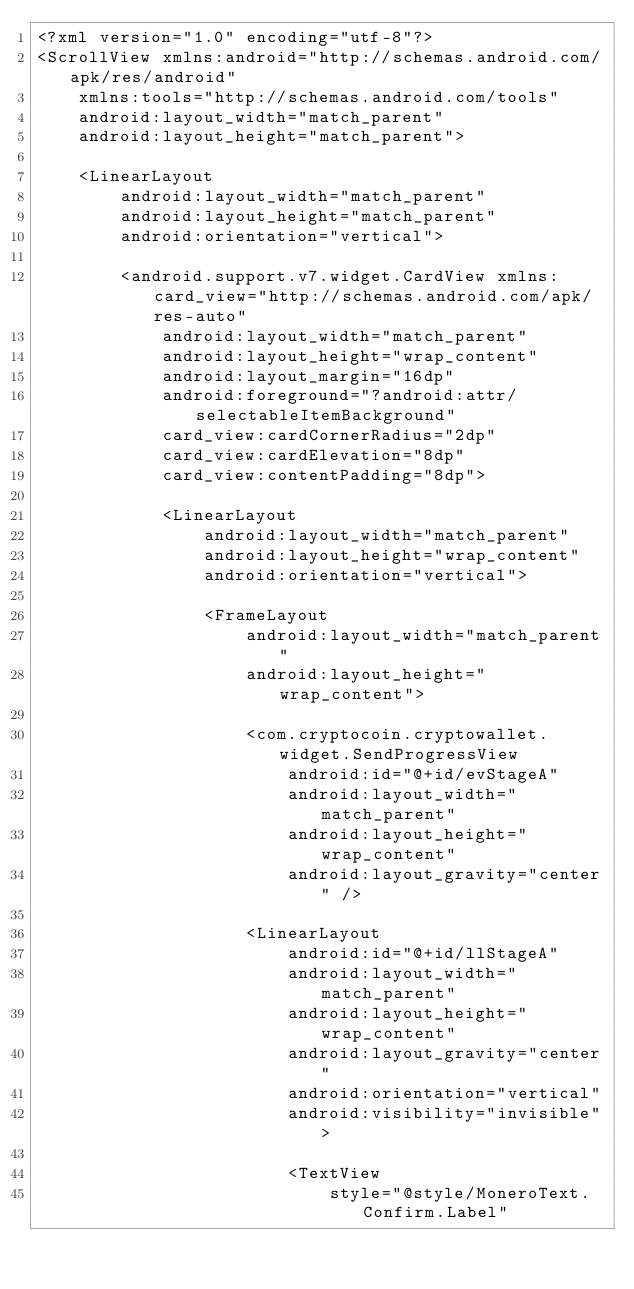Convert code to text. <code><loc_0><loc_0><loc_500><loc_500><_XML_><?xml version="1.0" encoding="utf-8"?>
<ScrollView xmlns:android="http://schemas.android.com/apk/res/android"
    xmlns:tools="http://schemas.android.com/tools"
    android:layout_width="match_parent"
    android:layout_height="match_parent">

    <LinearLayout
        android:layout_width="match_parent"
        android:layout_height="match_parent"
        android:orientation="vertical">

        <android.support.v7.widget.CardView xmlns:card_view="http://schemas.android.com/apk/res-auto"
            android:layout_width="match_parent"
            android:layout_height="wrap_content"
            android:layout_margin="16dp"
            android:foreground="?android:attr/selectableItemBackground"
            card_view:cardCornerRadius="2dp"
            card_view:cardElevation="8dp"
            card_view:contentPadding="8dp">

            <LinearLayout
                android:layout_width="match_parent"
                android:layout_height="wrap_content"
                android:orientation="vertical">

                <FrameLayout
                    android:layout_width="match_parent"
                    android:layout_height="wrap_content">

                    <com.cryptocoin.cryptowallet.widget.SendProgressView
                        android:id="@+id/evStageA"
                        android:layout_width="match_parent"
                        android:layout_height="wrap_content"
                        android:layout_gravity="center" />

                    <LinearLayout
                        android:id="@+id/llStageA"
                        android:layout_width="match_parent"
                        android:layout_height="wrap_content"
                        android:layout_gravity="center"
                        android:orientation="vertical"
                        android:visibility="invisible">

                        <TextView
                            style="@style/MoneroText.Confirm.Label"</code> 